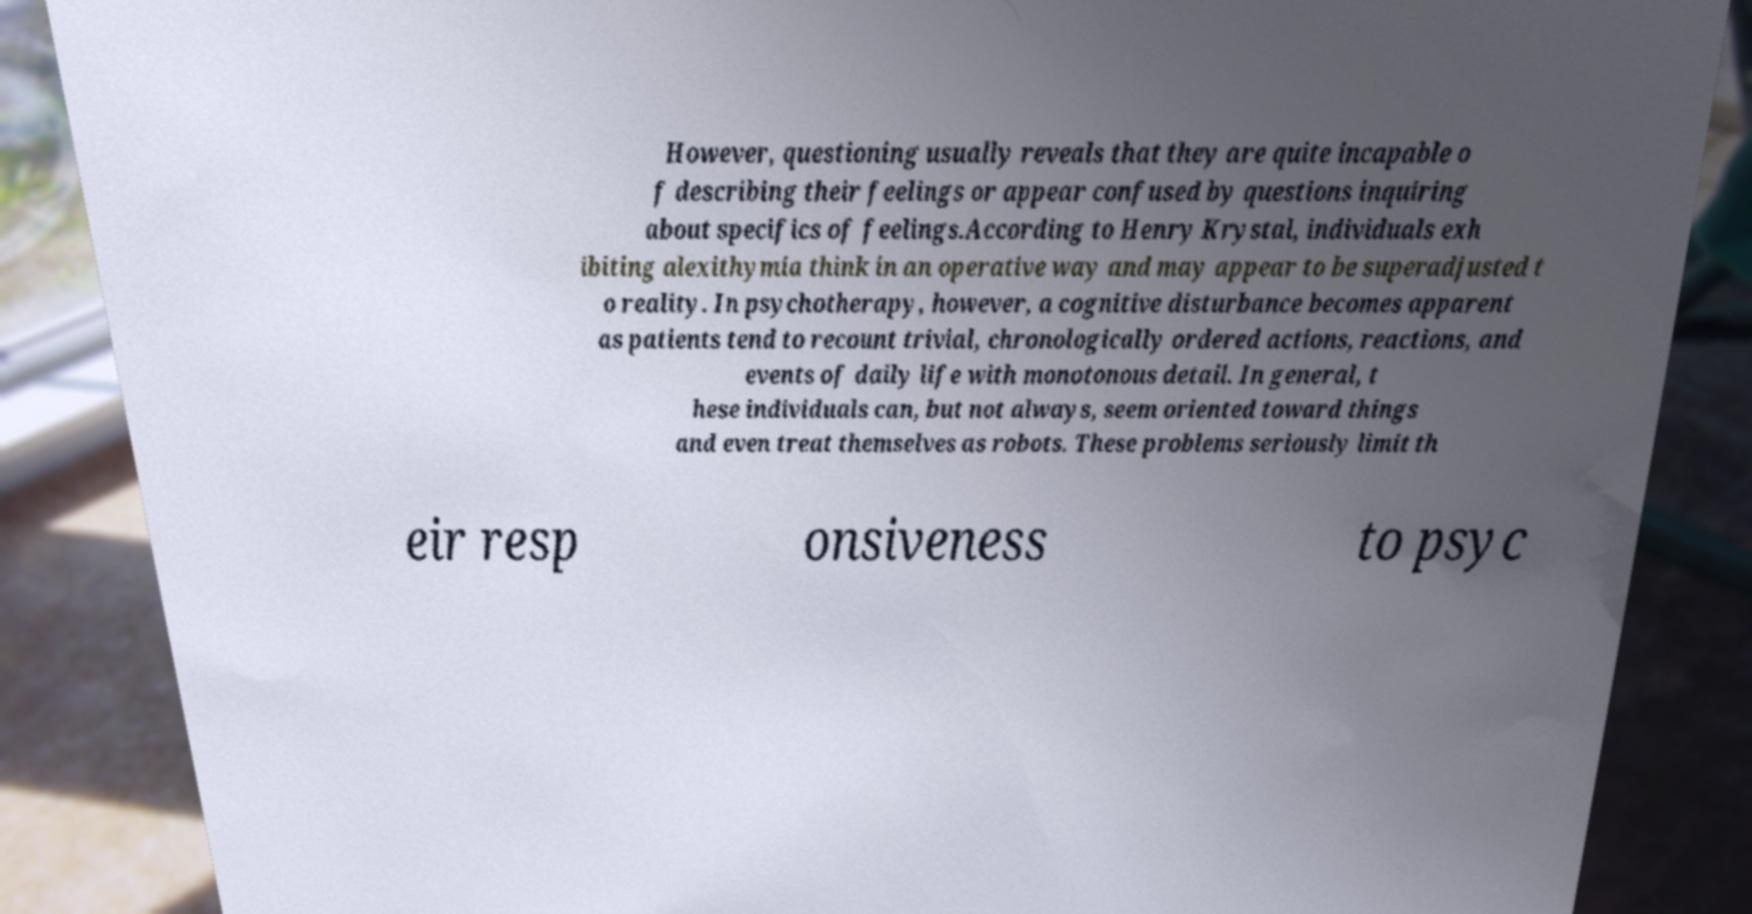Can you accurately transcribe the text from the provided image for me? However, questioning usually reveals that they are quite incapable o f describing their feelings or appear confused by questions inquiring about specifics of feelings.According to Henry Krystal, individuals exh ibiting alexithymia think in an operative way and may appear to be superadjusted t o reality. In psychotherapy, however, a cognitive disturbance becomes apparent as patients tend to recount trivial, chronologically ordered actions, reactions, and events of daily life with monotonous detail. In general, t hese individuals can, but not always, seem oriented toward things and even treat themselves as robots. These problems seriously limit th eir resp onsiveness to psyc 